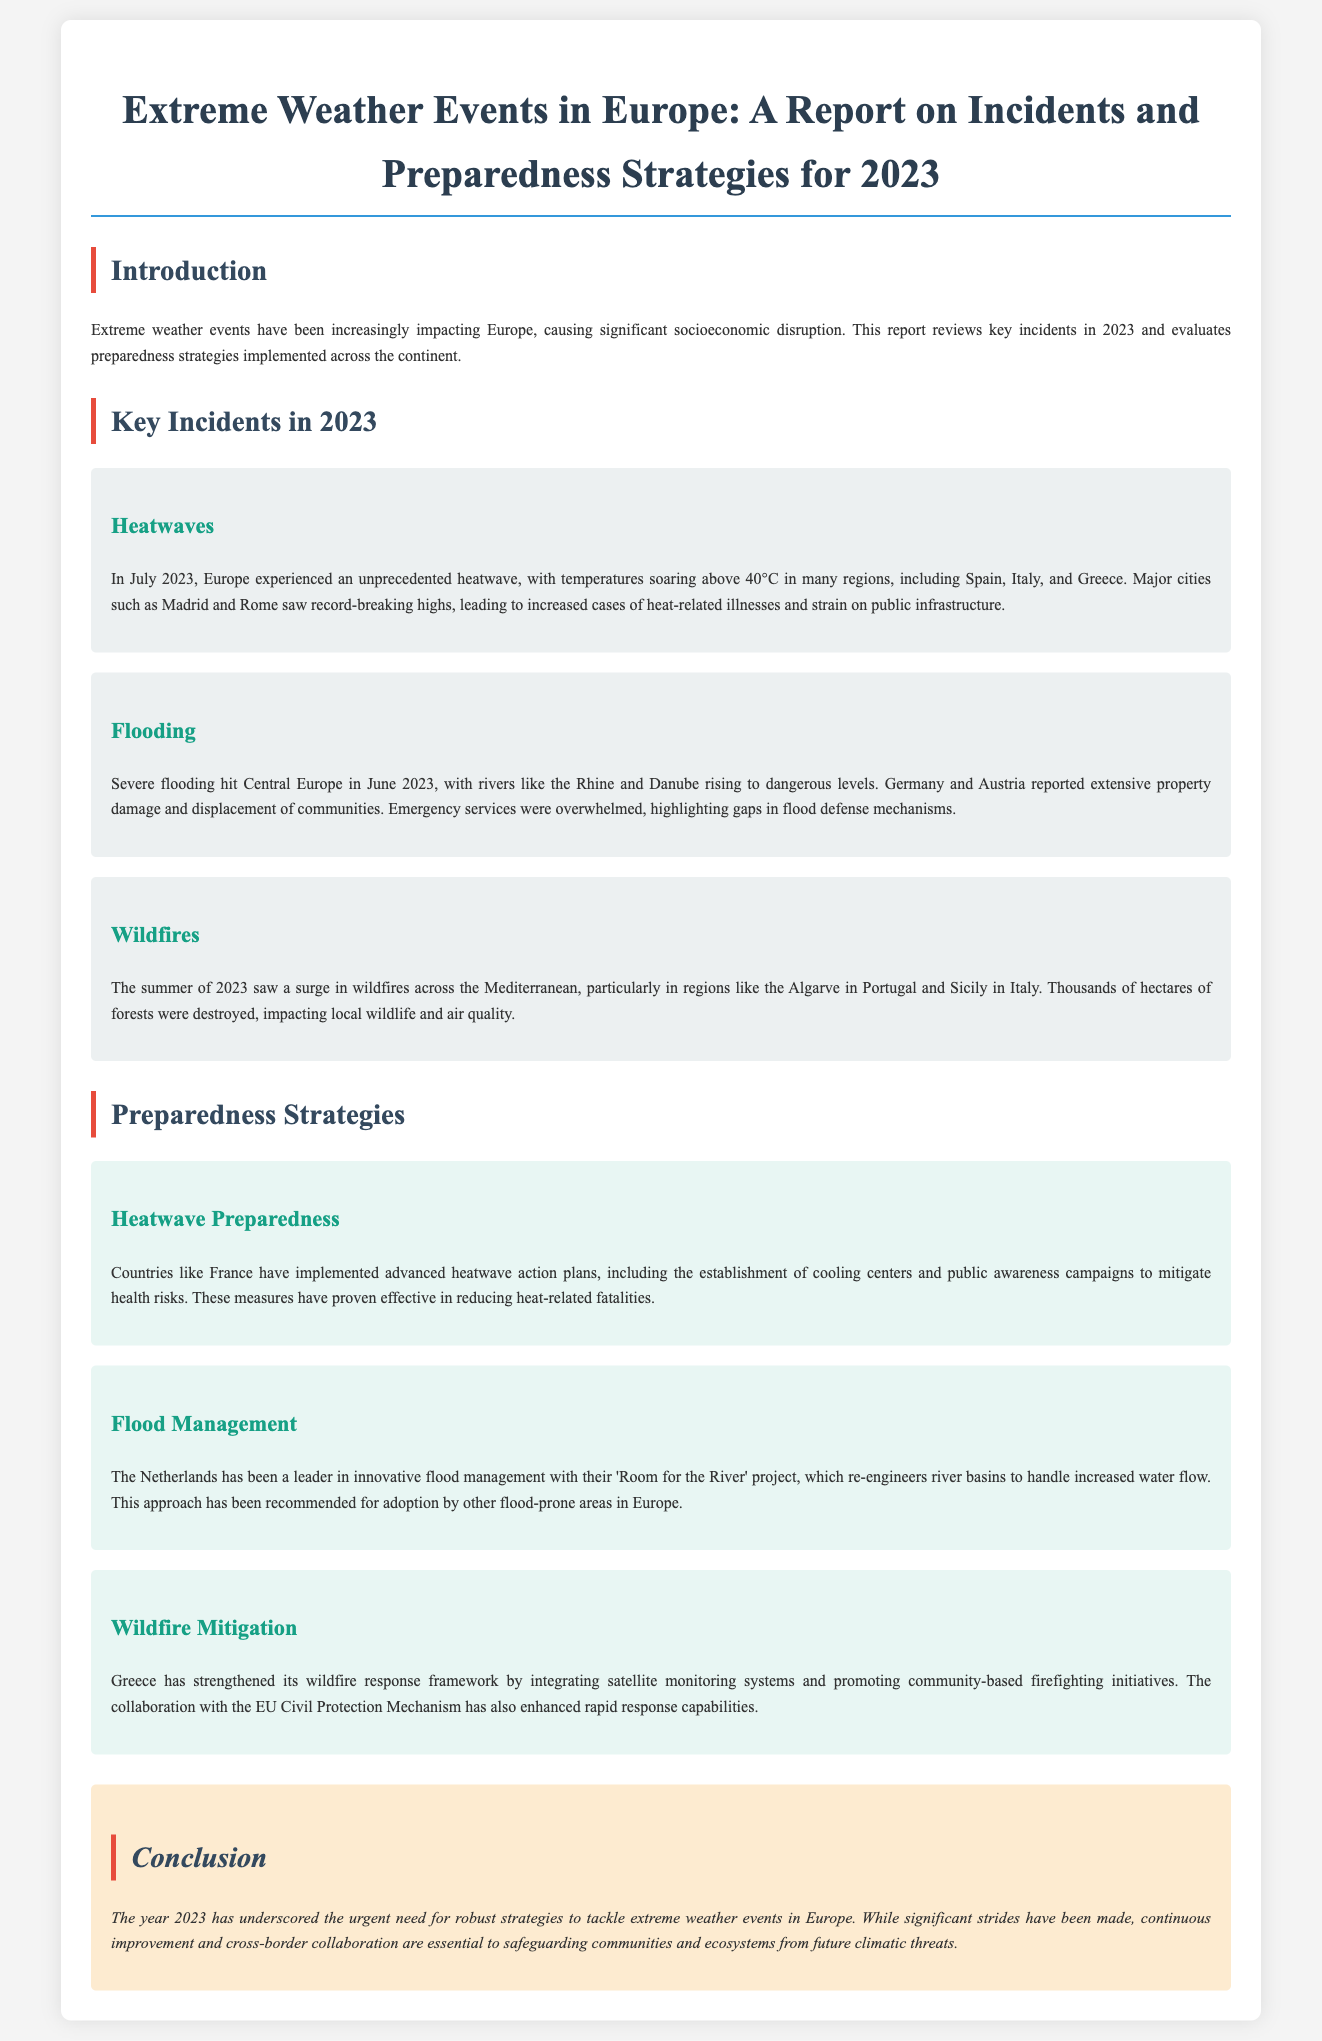What was the temperature in Europe during the heatwave in July 2023? The heatwave saw temperatures soaring above 40°C in many regions, including Spain, Italy, and Greece.
Answer: 40°C Which countries reported extensive property damage due to flooding in June 2023? Germany and Austria reported extensive property damage and displacement of communities due to severe flooding.
Answer: Germany and Austria What innovative flood management project is associated with the Netherlands? The Netherlands has been a leader in innovative flood management with their 'Room for the River' project.
Answer: Room for the River What did Greece integrate into its wildfire response framework? Greece strengthened its wildfire response framework by integrating satellite monitoring systems.
Answer: Satellite monitoring systems How many hectares of forests were destroyed due to wildfires in the summer of 2023? The document specifies a surge in wildfires that destroyed thousands of hectares of forests across the Mediterranean.
Answer: Thousands of hectares What was one of the effective measures implemented by France during heatwaves? France implemented advanced heatwave action plans, including the establishment of cooling centers.
Answer: Cooling centers In which region of Portugal did wildfires occur in 2023? The Algarve region in Portugal saw significant wildfires during the summer of 2023.
Answer: Algarve What is the main emphasis of the conclusion in the report? The conclusion underscores the urgent need for robust strategies to tackle extreme weather events in Europe.
Answer: Robust strategies 